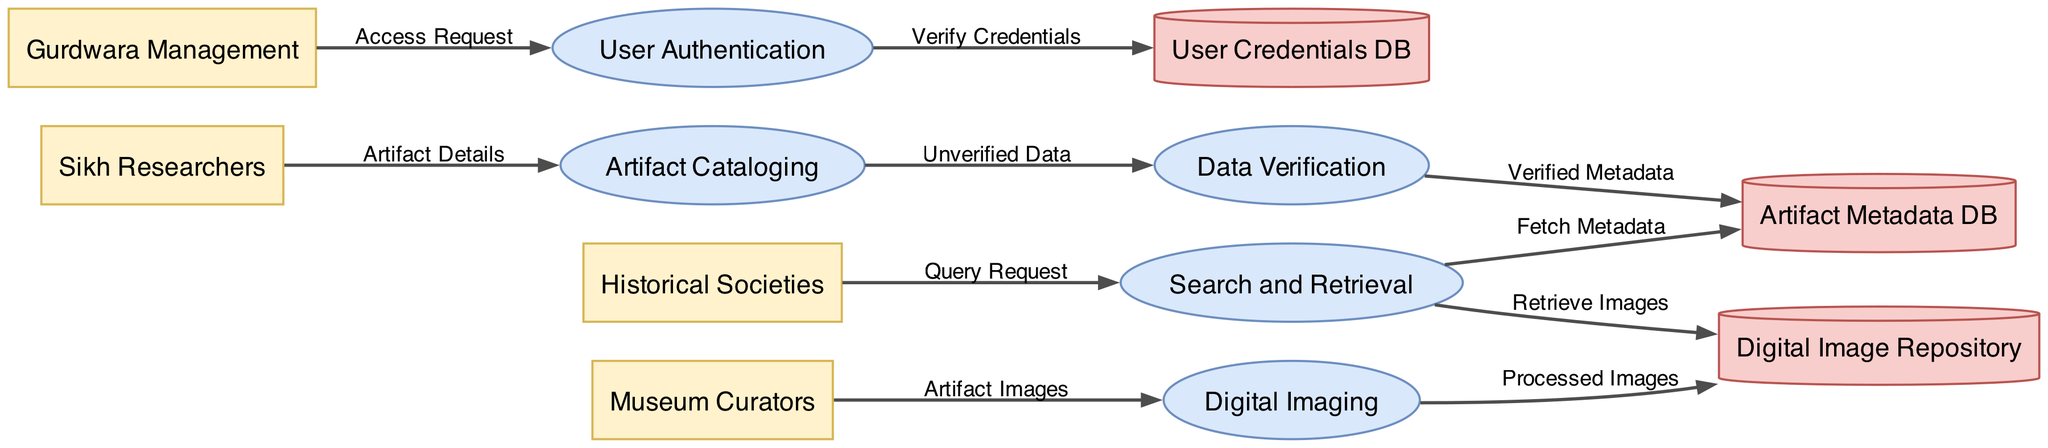What are the external entities in the diagram? The external entities listed in the diagram are: Sikh Researchers, Museum Curators, Gurdwara Management, and Historical Societies. These entities represent the users who interact with the data management system.
Answer: Sikh Researchers, Museum Curators, Gurdwara Management, Historical Societies Which process is responsible for artifact verification? The process responsible for artifact verification is Data Verification. It is indicated as one of the main processes in the diagram, showing where unverified data flows to be checked.
Answer: Data Verification How many data stores are there in the diagram? The diagram includes three data stores, which are: Artifact Metadata DB, Digital Image Repository, and User Credentials DB. A simple count of these nodes confirms the total.
Answer: 3 What flows from Artifact Cataloging to Data Verification? The flow from Artifact Cataloging to Data Verification is labeled Unverified Data. It indicates that the metadata collected during cataloging is sent for verification.
Answer: Unverified Data What is the relationship between Museum Curators and Digital Imaging? Museum Curators provide Artifact Images to the Digital Imaging process, which is shown as a direct data flow to that process. This outlines their role in supplying images for digitization.
Answer: Artifact Images Which data store retrieves images in the Search and Retrieval process? The data store that retrieves images during the Search and Retrieval process is the Digital Image Repository. It indicates where images are stored and accessed from for user queries.
Answer: Digital Image Repository What is the sequence of processes from Artifact Cataloging to the data store? The sequence includes: Artifact Cataloging sends Unverified Data to Data Verification, which then sends Verified Metadata to the Artifact Metadata DB. This denotes the complete flow of data from initial cataloging to storage.
Answer: Artifact Cataloging → Data Verification → Artifact Metadata DB Which external entity requests access in the User Authentication process? Gurdwara Management is the external entity that requests access in the User Authentication process, as indicated by the flow of Access Request from this entity.
Answer: Gurdwara Management What type of document is represented by the Digital Image Repository? The Digital Image Repository represents a data store, where processed images from the Digital Imaging process are stored. It is indicated in the diagram as a cylinder, which designates it as a data storage component.
Answer: Data store 